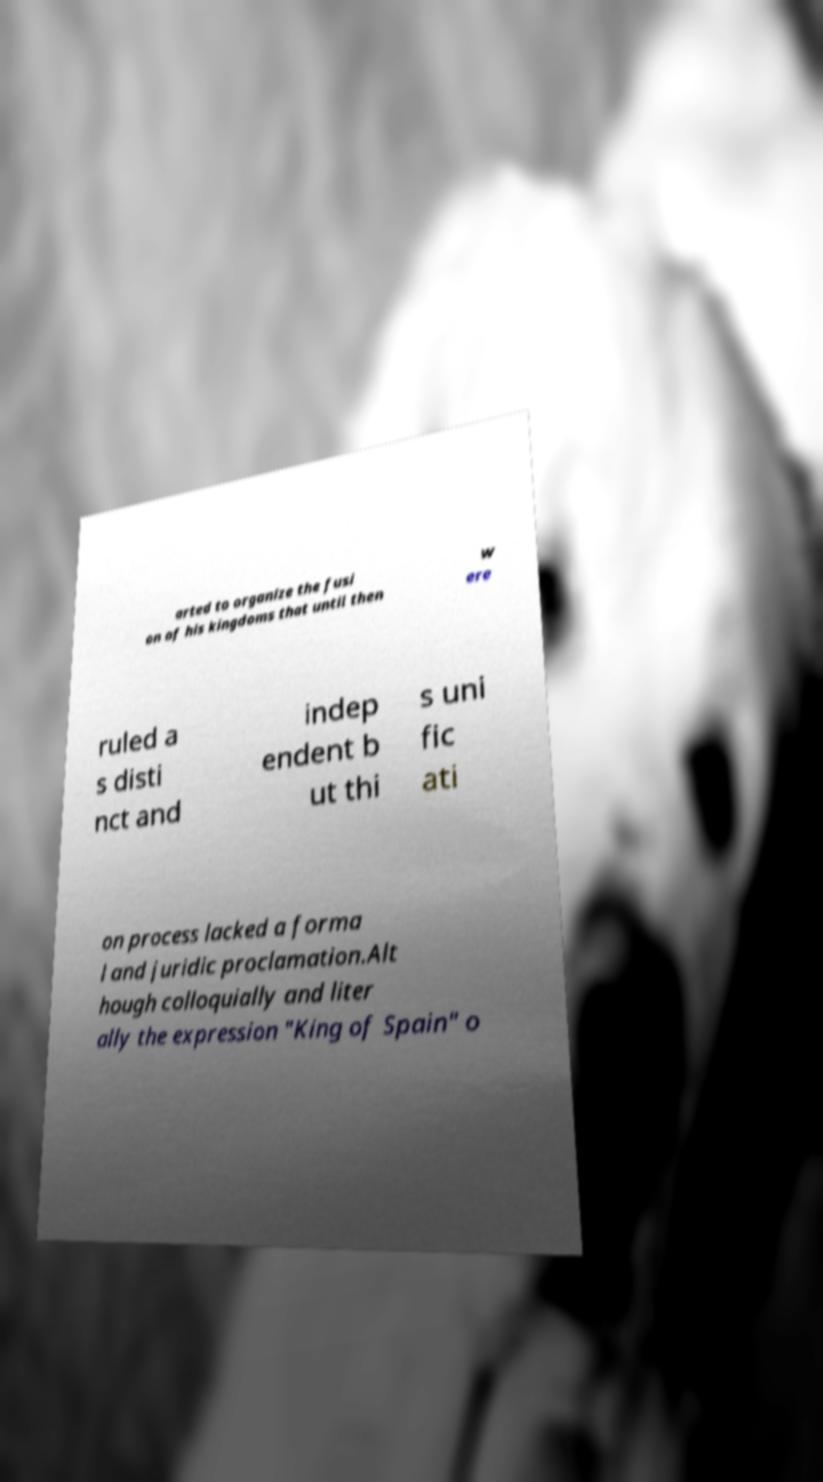There's text embedded in this image that I need extracted. Can you transcribe it verbatim? arted to organize the fusi on of his kingdoms that until then w ere ruled a s disti nct and indep endent b ut thi s uni fic ati on process lacked a forma l and juridic proclamation.Alt hough colloquially and liter ally the expression "King of Spain" o 